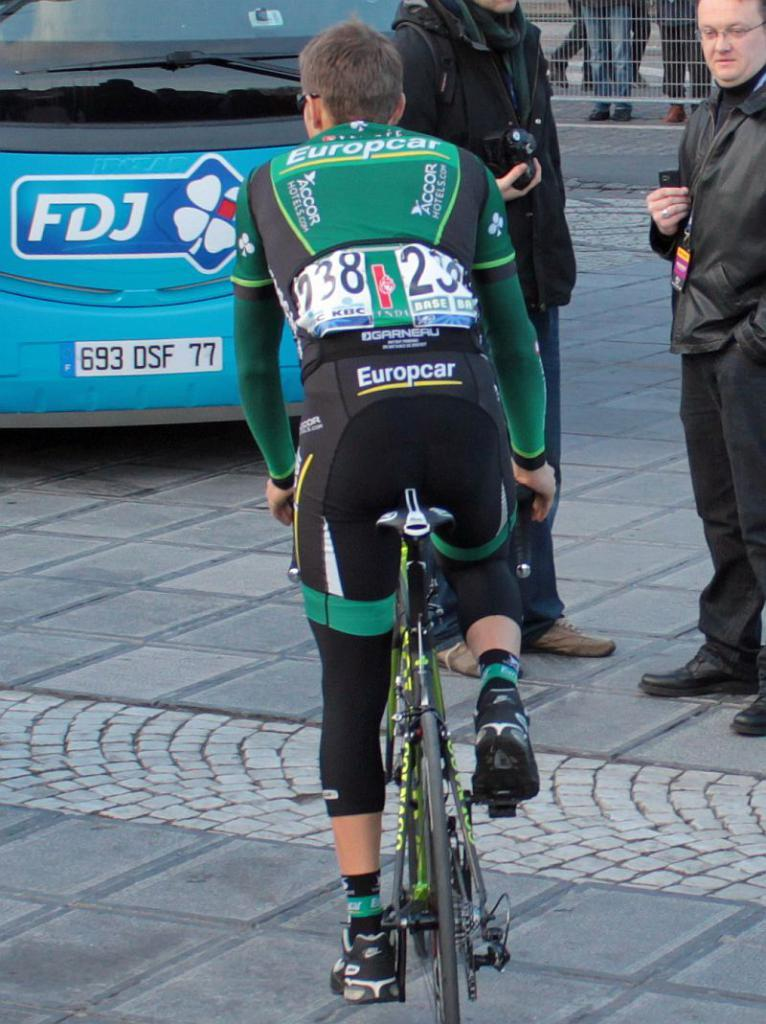What is the man in the image doing? The man is riding a bicycle on the road. Can you describe the vehicle behind the man? There is a car behind the man. What are the people standing nearby doing? The people standing nearby are holding cameras. How many sheep can be seen in the image? There are no sheep present in the image. What suggestion is being made by the man on the bicycle? The image does not provide any information about a suggestion being made by the man on the bicycle. 